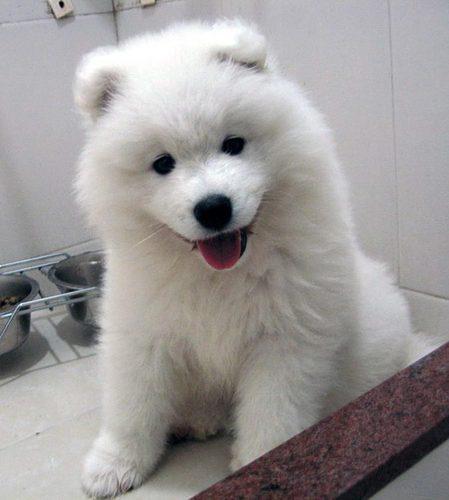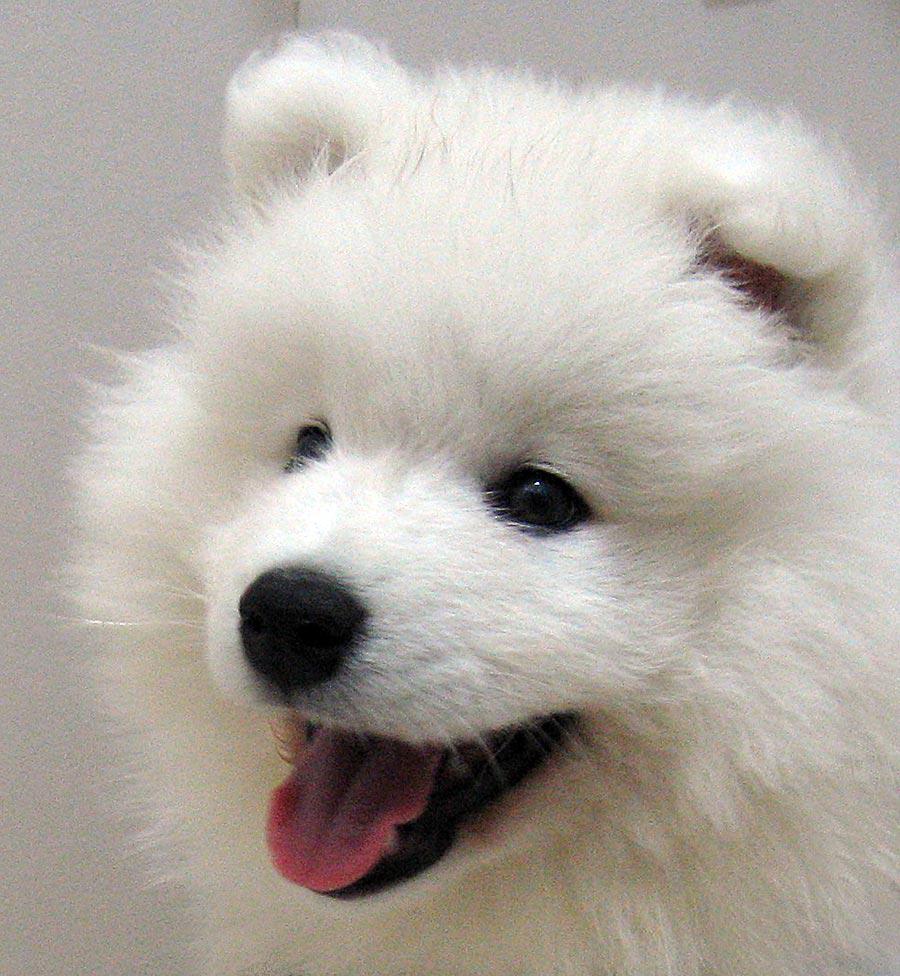The first image is the image on the left, the second image is the image on the right. For the images displayed, is the sentence "At least one dog's tongue is visible." factually correct? Answer yes or no. Yes. The first image is the image on the left, the second image is the image on the right. For the images displayed, is the sentence "In one image there is a dog outside in the center of the image." factually correct? Answer yes or no. No. 